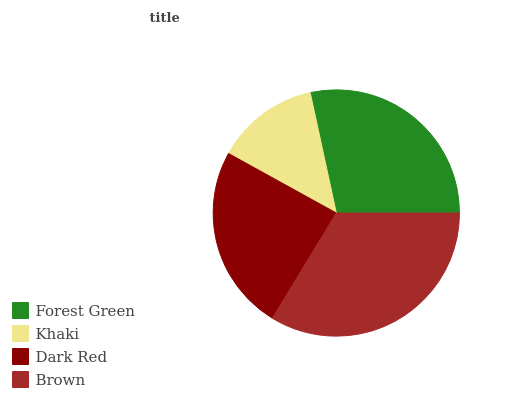Is Khaki the minimum?
Answer yes or no. Yes. Is Brown the maximum?
Answer yes or no. Yes. Is Dark Red the minimum?
Answer yes or no. No. Is Dark Red the maximum?
Answer yes or no. No. Is Dark Red greater than Khaki?
Answer yes or no. Yes. Is Khaki less than Dark Red?
Answer yes or no. Yes. Is Khaki greater than Dark Red?
Answer yes or no. No. Is Dark Red less than Khaki?
Answer yes or no. No. Is Forest Green the high median?
Answer yes or no. Yes. Is Dark Red the low median?
Answer yes or no. Yes. Is Brown the high median?
Answer yes or no. No. Is Forest Green the low median?
Answer yes or no. No. 